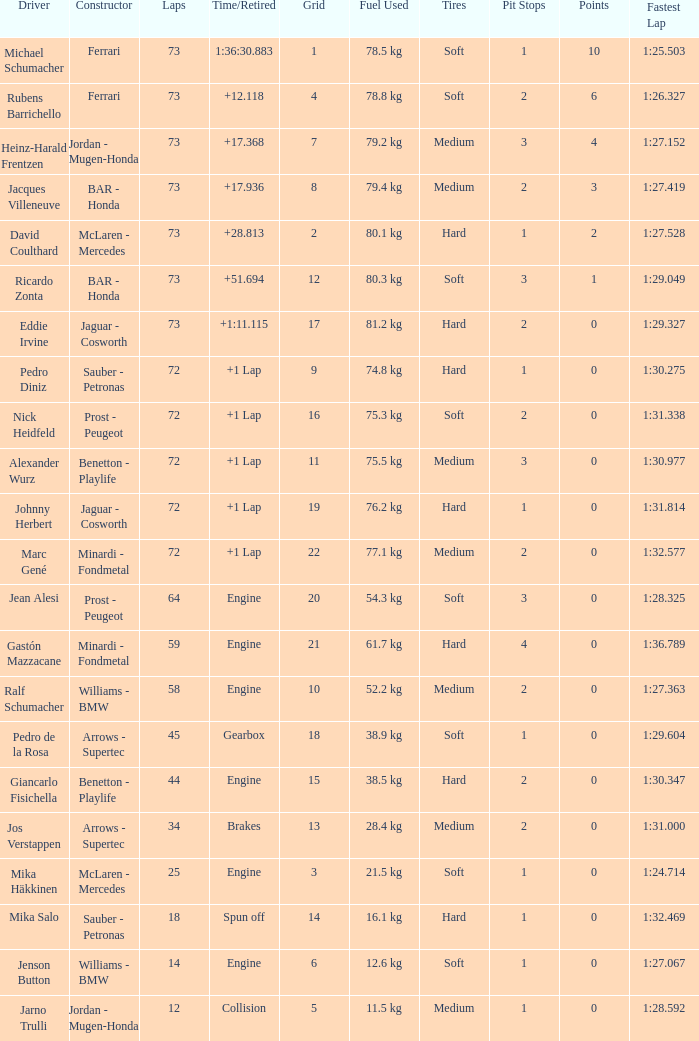How many laps did Giancarlo Fisichella do with a grid larger than 15? 0.0. 